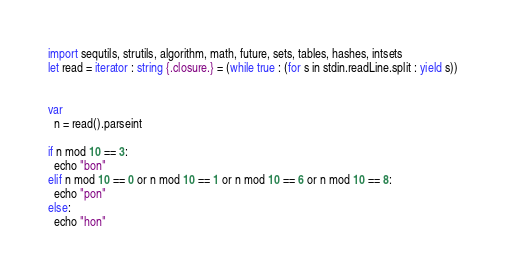Convert code to text. <code><loc_0><loc_0><loc_500><loc_500><_Nim_>import sequtils, strutils, algorithm, math, future, sets, tables, hashes, intsets
let read = iterator : string {.closure.} = (while true : (for s in stdin.readLine.split : yield s))


var
  n = read().parseint

if n mod 10 == 3:
  echo "bon"
elif n mod 10 == 0 or n mod 10 == 1 or n mod 10 == 6 or n mod 10 == 8:
  echo "pon"
else:
  echo "hon"







</code> 